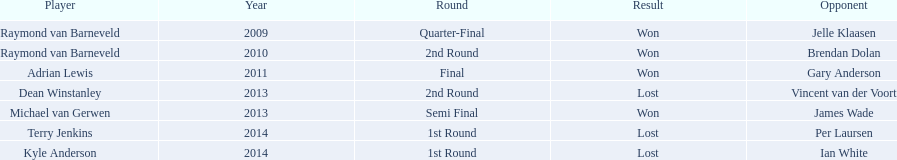Did terry jenkins win in 2014? Terry Jenkins, Lost. If terry jenkins lost who won? Per Laursen. 